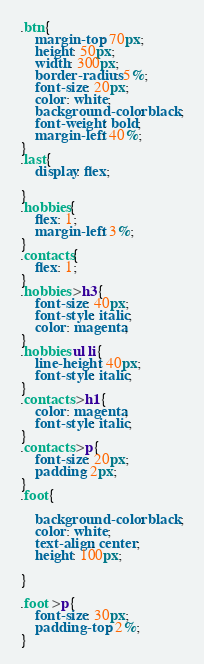<code> <loc_0><loc_0><loc_500><loc_500><_CSS_>.btn{
    margin-top: 70px;
    height: 50px;
    width: 300px;
    border-radius: 5%;
    font-size: 20px;
    color: white;
    background-color: black;
    font-weight: bold;
    margin-left: 40%;
}
.last{
    display: flex;

}
.hobbies{
    flex: 1;
    margin-left: 3%;
}
.contacts{
    flex: 1;
}
.hobbies >h3{
    font-size: 40px;
    font-style: italic;
    color: magenta;
}
.hobbies ul li{
    line-height: 40px;
    font-style: italic;
}
.contacts >h1{
    color: magenta; 
    font-style: italic;
}
.contacts >p{
    font-size: 20px;
    padding: 2px;
}
.foot{
  
    background-color: black;
    color: white;
    text-align: center;
    height: 100px;
   
}

.foot >p{
    font-size: 30px;
    padding-top: 2%;
}  </code> 